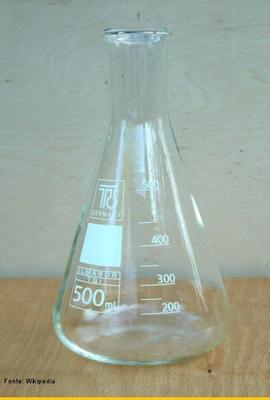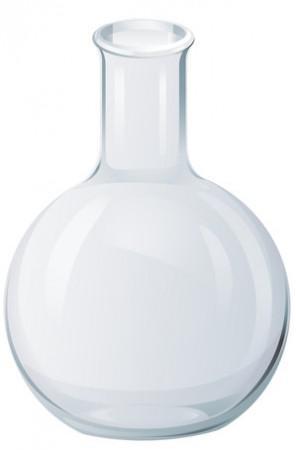The first image is the image on the left, the second image is the image on the right. Given the left and right images, does the statement "An image contains just one beaker, which is cylinder shaped." hold true? Answer yes or no. No. The first image is the image on the left, the second image is the image on the right. Given the left and right images, does the statement "One or more beakers in one image are partially filled with colored liquid, while the one beaker in the other image is triangular shaped and empty." hold true? Answer yes or no. No. 